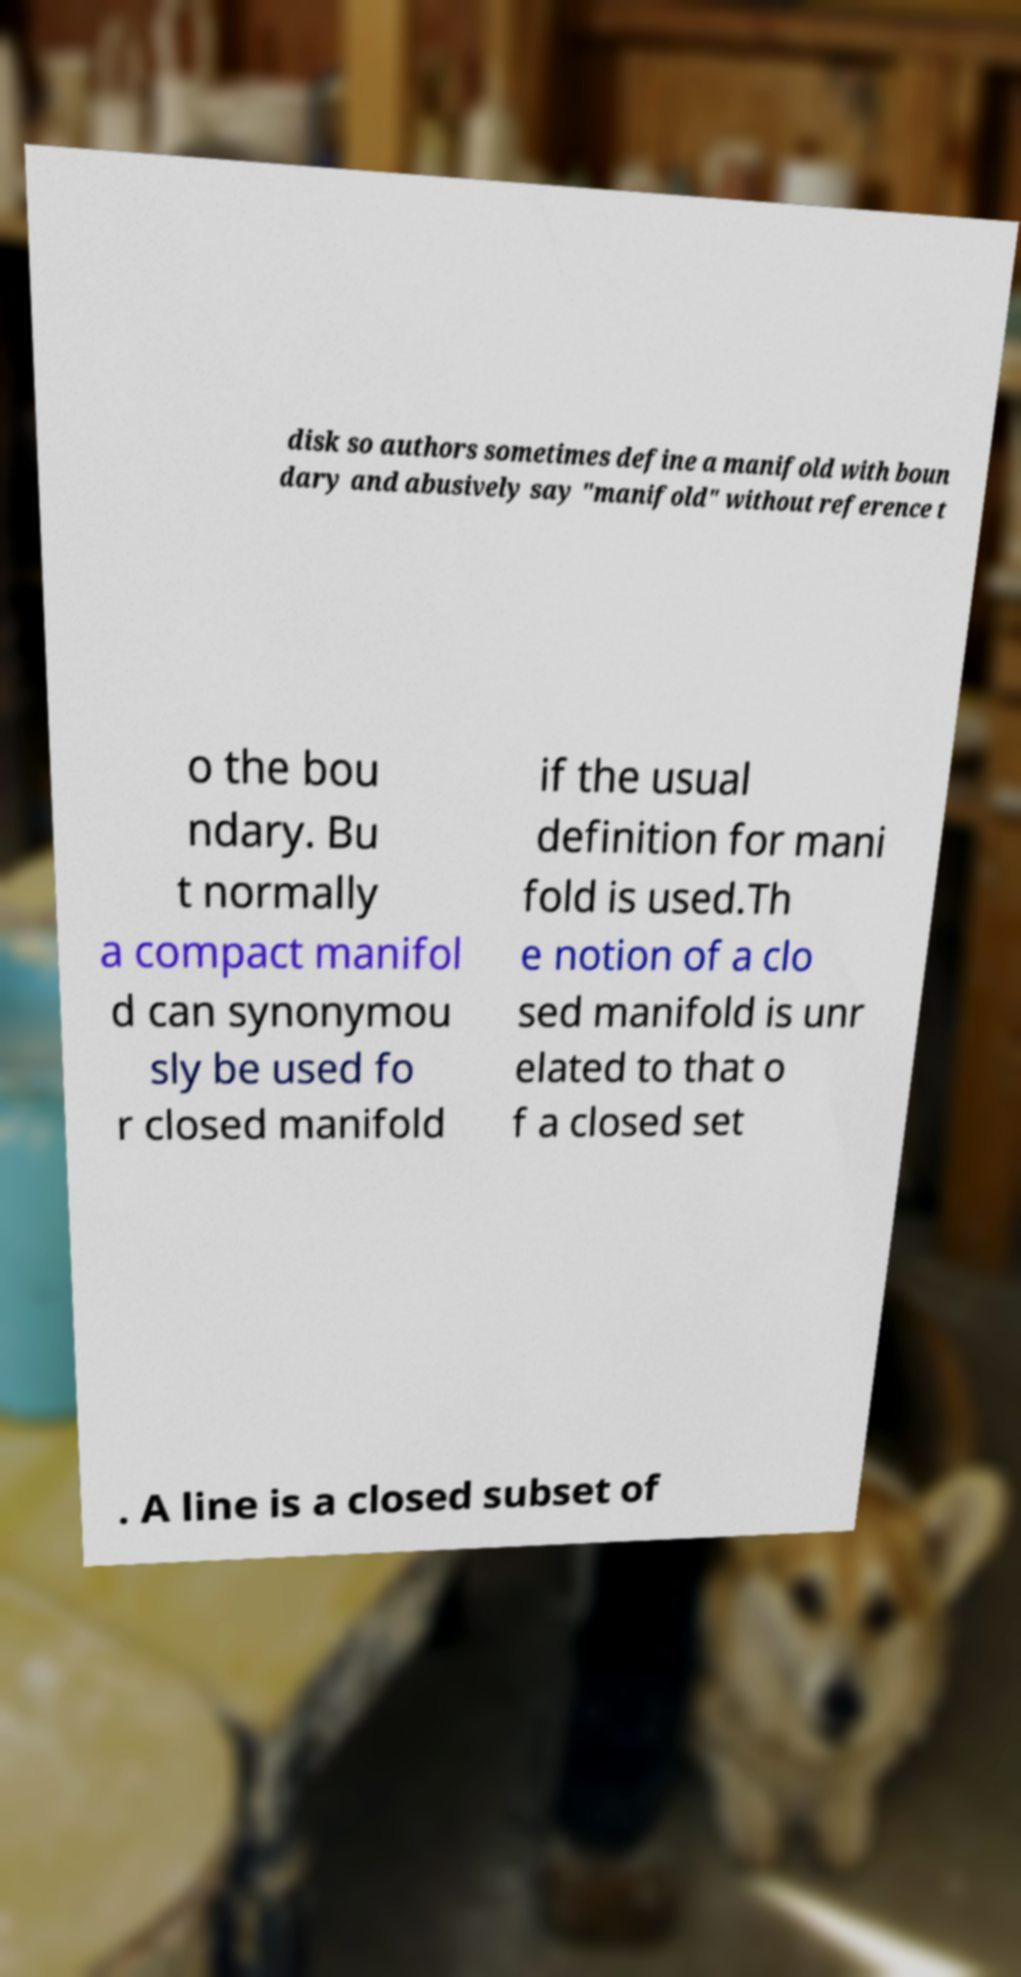For documentation purposes, I need the text within this image transcribed. Could you provide that? disk so authors sometimes define a manifold with boun dary and abusively say "manifold" without reference t o the bou ndary. Bu t normally a compact manifol d can synonymou sly be used fo r closed manifold if the usual definition for mani fold is used.Th e notion of a clo sed manifold is unr elated to that o f a closed set . A line is a closed subset of 